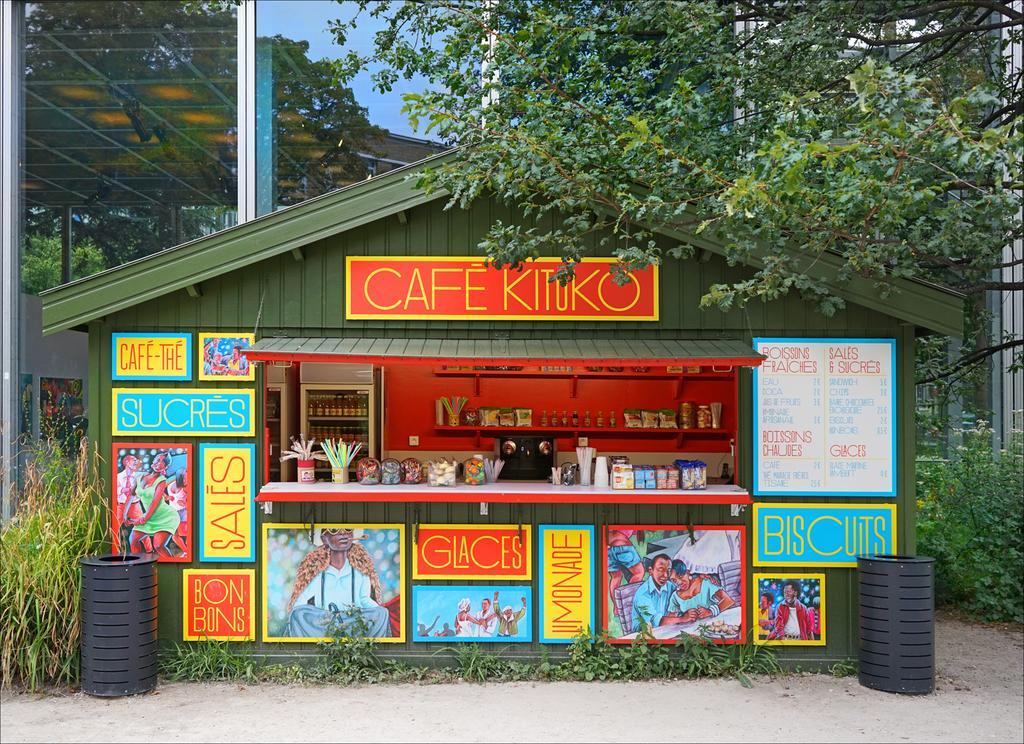Please provide a concise description of this image. In this picture we can observe a store. There are different types of boards fixed to the wall of the store. The store is in green color and we can observe blue, red and yellow color boards. There are two black color containers on either sides of this store. We can observe some plants and trees. In the background there is a sky. 